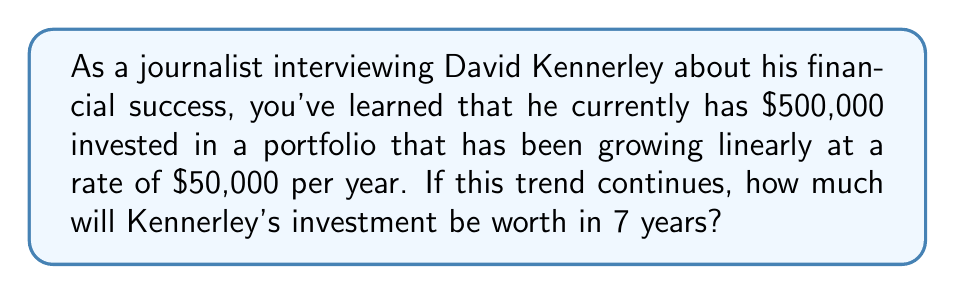Give your solution to this math problem. To solve this problem, we can use a linear equation to model the growth of Kennerley's investment over time. Let's break it down step by step:

1. Define variables:
   Let $y$ be the value of the investment
   Let $x$ be the number of years from now

2. Create the linear equation:
   Initial value: $y_0 = 500,000$
   Rate of growth: $m = 50,000$ per year
   
   The linear equation is: $y = mx + y_0$
   
   Substituting the values: $y = 50,000x + 500,000$

3. Calculate the value after 7 years:
   $x = 7$
   
   $y = 50,000(7) + 500,000$
   $y = 350,000 + 500,000$
   $y = 850,000$

Therefore, using this linear projection, Kennerley's investment will be worth $850,000 in 7 years.

It's important to note that this is a simplified model. In reality, investment growth is often non-linear and subject to market fluctuations. However, for the purposes of a quick estimate or interview discussion, this linear projection can provide a useful baseline.
Answer: $850,000 